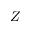Convert formula to latex. <formula><loc_0><loc_0><loc_500><loc_500>Z</formula> 